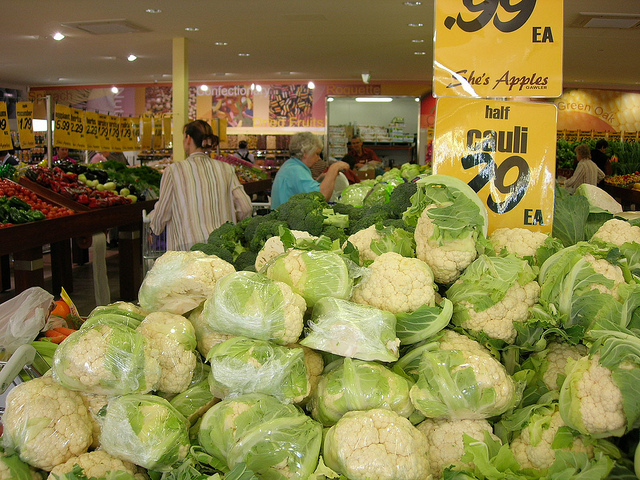Can you tell me the price of the vegetable that is most prominent in the photo? Certainly, the most prominent vegetable in the photo, the cauliflower, is displayed with a price tag reading '99¢ each.' 